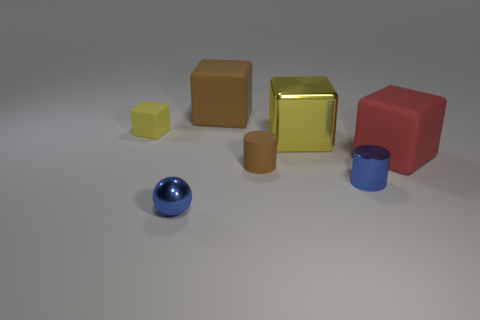What number of things are either cubes on the left side of the metallic sphere or matte cubes that are to the right of the small brown matte thing?
Make the answer very short. 2. There is a tiny brown rubber object that is in front of the red object; how many big brown cubes are to the right of it?
Offer a terse response. 0. Does the small blue thing to the left of the large yellow object have the same shape as the yellow object that is right of the tiny yellow rubber object?
Provide a short and direct response. No. There is a shiny thing that is the same color as the small block; what is its shape?
Ensure brevity in your answer.  Cube. Is there a gray sphere made of the same material as the blue sphere?
Make the answer very short. No. What number of matte objects are small gray things or large brown cubes?
Keep it short and to the point. 1. What shape is the small blue thing right of the big block that is behind the yellow metal block?
Provide a succinct answer. Cylinder. Are there fewer small blue balls left of the yellow metal cube than large purple balls?
Keep it short and to the point. No. There is a small yellow matte thing; what shape is it?
Ensure brevity in your answer.  Cube. There is a yellow cube that is behind the large yellow object; what size is it?
Give a very brief answer. Small. 